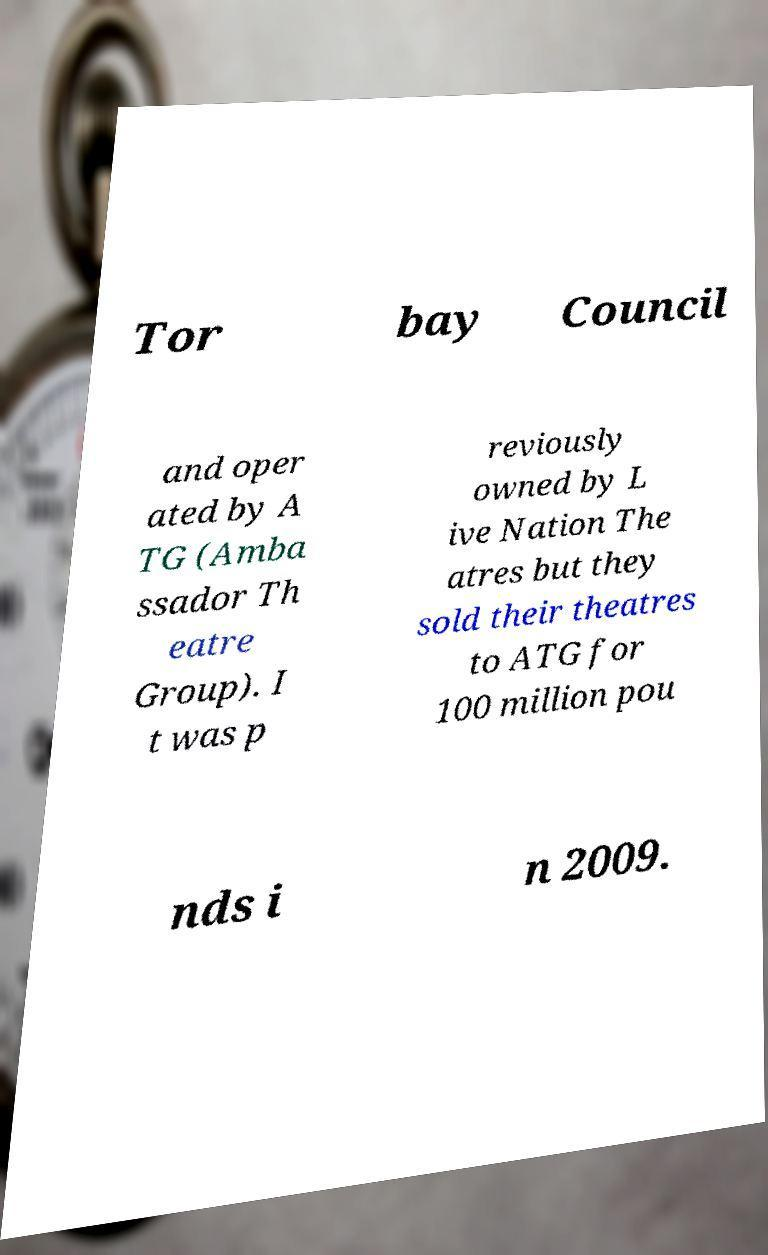What messages or text are displayed in this image? I need them in a readable, typed format. Tor bay Council and oper ated by A TG (Amba ssador Th eatre Group). I t was p reviously owned by L ive Nation The atres but they sold their theatres to ATG for 100 million pou nds i n 2009. 